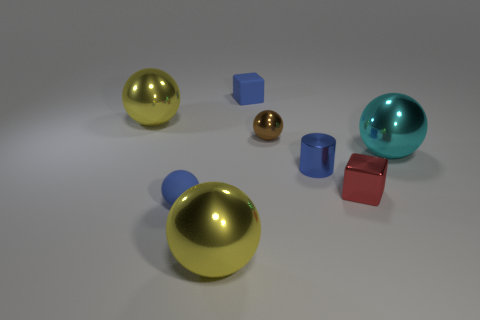Add 1 large cyan rubber cylinders. How many objects exist? 9 Subtract all large cyan spheres. How many spheres are left? 4 Subtract all red blocks. How many blocks are left? 1 Subtract all cubes. How many objects are left? 6 Subtract 1 spheres. How many spheres are left? 4 Subtract all cyan things. Subtract all small blue spheres. How many objects are left? 6 Add 1 metal things. How many metal things are left? 7 Add 5 red metallic cubes. How many red metallic cubes exist? 6 Subtract 0 cyan cylinders. How many objects are left? 8 Subtract all red balls. Subtract all yellow cylinders. How many balls are left? 5 